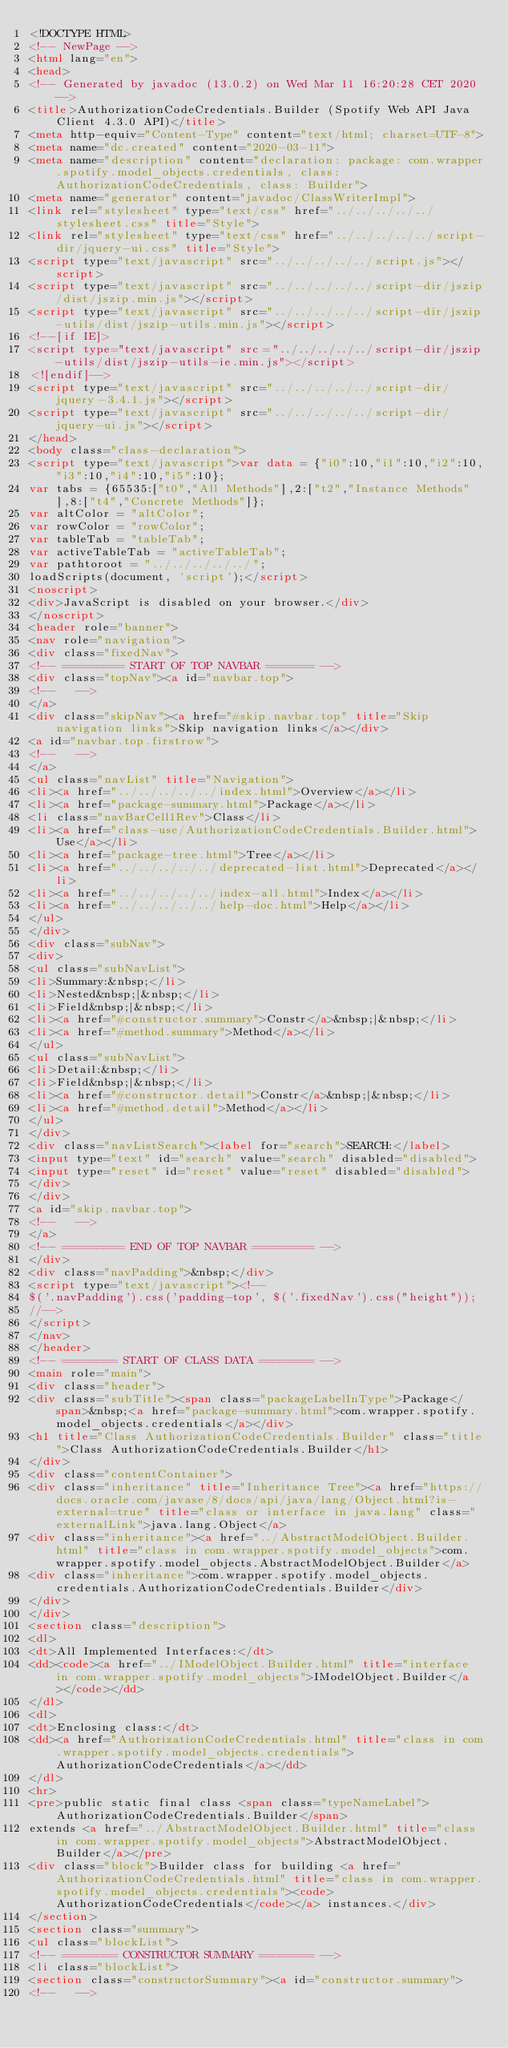Convert code to text. <code><loc_0><loc_0><loc_500><loc_500><_HTML_><!DOCTYPE HTML>
<!-- NewPage -->
<html lang="en">
<head>
<!-- Generated by javadoc (13.0.2) on Wed Mar 11 16:20:28 CET 2020 -->
<title>AuthorizationCodeCredentials.Builder (Spotify Web API Java Client 4.3.0 API)</title>
<meta http-equiv="Content-Type" content="text/html; charset=UTF-8">
<meta name="dc.created" content="2020-03-11">
<meta name="description" content="declaration: package: com.wrapper.spotify.model_objects.credentials, class: AuthorizationCodeCredentials, class: Builder">
<meta name="generator" content="javadoc/ClassWriterImpl">
<link rel="stylesheet" type="text/css" href="../../../../../stylesheet.css" title="Style">
<link rel="stylesheet" type="text/css" href="../../../../../script-dir/jquery-ui.css" title="Style">
<script type="text/javascript" src="../../../../../script.js"></script>
<script type="text/javascript" src="../../../../../script-dir/jszip/dist/jszip.min.js"></script>
<script type="text/javascript" src="../../../../../script-dir/jszip-utils/dist/jszip-utils.min.js"></script>
<!--[if IE]>
<script type="text/javascript" src="../../../../../script-dir/jszip-utils/dist/jszip-utils-ie.min.js"></script>
<![endif]-->
<script type="text/javascript" src="../../../../../script-dir/jquery-3.4.1.js"></script>
<script type="text/javascript" src="../../../../../script-dir/jquery-ui.js"></script>
</head>
<body class="class-declaration">
<script type="text/javascript">var data = {"i0":10,"i1":10,"i2":10,"i3":10,"i4":10,"i5":10};
var tabs = {65535:["t0","All Methods"],2:["t2","Instance Methods"],8:["t4","Concrete Methods"]};
var altColor = "altColor";
var rowColor = "rowColor";
var tableTab = "tableTab";
var activeTableTab = "activeTableTab";
var pathtoroot = "../../../../../";
loadScripts(document, 'script');</script>
<noscript>
<div>JavaScript is disabled on your browser.</div>
</noscript>
<header role="banner">
<nav role="navigation">
<div class="fixedNav">
<!-- ========= START OF TOP NAVBAR ======= -->
<div class="topNav"><a id="navbar.top">
<!--   -->
</a>
<div class="skipNav"><a href="#skip.navbar.top" title="Skip navigation links">Skip navigation links</a></div>
<a id="navbar.top.firstrow">
<!--   -->
</a>
<ul class="navList" title="Navigation">
<li><a href="../../../../../index.html">Overview</a></li>
<li><a href="package-summary.html">Package</a></li>
<li class="navBarCell1Rev">Class</li>
<li><a href="class-use/AuthorizationCodeCredentials.Builder.html">Use</a></li>
<li><a href="package-tree.html">Tree</a></li>
<li><a href="../../../../../deprecated-list.html">Deprecated</a></li>
<li><a href="../../../../../index-all.html">Index</a></li>
<li><a href="../../../../../help-doc.html">Help</a></li>
</ul>
</div>
<div class="subNav">
<div>
<ul class="subNavList">
<li>Summary:&nbsp;</li>
<li>Nested&nbsp;|&nbsp;</li>
<li>Field&nbsp;|&nbsp;</li>
<li><a href="#constructor.summary">Constr</a>&nbsp;|&nbsp;</li>
<li><a href="#method.summary">Method</a></li>
</ul>
<ul class="subNavList">
<li>Detail:&nbsp;</li>
<li>Field&nbsp;|&nbsp;</li>
<li><a href="#constructor.detail">Constr</a>&nbsp;|&nbsp;</li>
<li><a href="#method.detail">Method</a></li>
</ul>
</div>
<div class="navListSearch"><label for="search">SEARCH:</label>
<input type="text" id="search" value="search" disabled="disabled">
<input type="reset" id="reset" value="reset" disabled="disabled">
</div>
</div>
<a id="skip.navbar.top">
<!--   -->
</a>
<!-- ========= END OF TOP NAVBAR ========= -->
</div>
<div class="navPadding">&nbsp;</div>
<script type="text/javascript"><!--
$('.navPadding').css('padding-top', $('.fixedNav').css("height"));
//-->
</script>
</nav>
</header>
<!-- ======== START OF CLASS DATA ======== -->
<main role="main">
<div class="header">
<div class="subTitle"><span class="packageLabelInType">Package</span>&nbsp;<a href="package-summary.html">com.wrapper.spotify.model_objects.credentials</a></div>
<h1 title="Class AuthorizationCodeCredentials.Builder" class="title">Class AuthorizationCodeCredentials.Builder</h1>
</div>
<div class="contentContainer">
<div class="inheritance" title="Inheritance Tree"><a href="https://docs.oracle.com/javase/8/docs/api/java/lang/Object.html?is-external=true" title="class or interface in java.lang" class="externalLink">java.lang.Object</a>
<div class="inheritance"><a href="../AbstractModelObject.Builder.html" title="class in com.wrapper.spotify.model_objects">com.wrapper.spotify.model_objects.AbstractModelObject.Builder</a>
<div class="inheritance">com.wrapper.spotify.model_objects.credentials.AuthorizationCodeCredentials.Builder</div>
</div>
</div>
<section class="description">
<dl>
<dt>All Implemented Interfaces:</dt>
<dd><code><a href="../IModelObject.Builder.html" title="interface in com.wrapper.spotify.model_objects">IModelObject.Builder</a></code></dd>
</dl>
<dl>
<dt>Enclosing class:</dt>
<dd><a href="AuthorizationCodeCredentials.html" title="class in com.wrapper.spotify.model_objects.credentials">AuthorizationCodeCredentials</a></dd>
</dl>
<hr>
<pre>public static final class <span class="typeNameLabel">AuthorizationCodeCredentials.Builder</span>
extends <a href="../AbstractModelObject.Builder.html" title="class in com.wrapper.spotify.model_objects">AbstractModelObject.Builder</a></pre>
<div class="block">Builder class for building <a href="AuthorizationCodeCredentials.html" title="class in com.wrapper.spotify.model_objects.credentials"><code>AuthorizationCodeCredentials</code></a> instances.</div>
</section>
<section class="summary">
<ul class="blockList">
<!-- ======== CONSTRUCTOR SUMMARY ======== -->
<li class="blockList">
<section class="constructorSummary"><a id="constructor.summary">
<!--   --></code> 